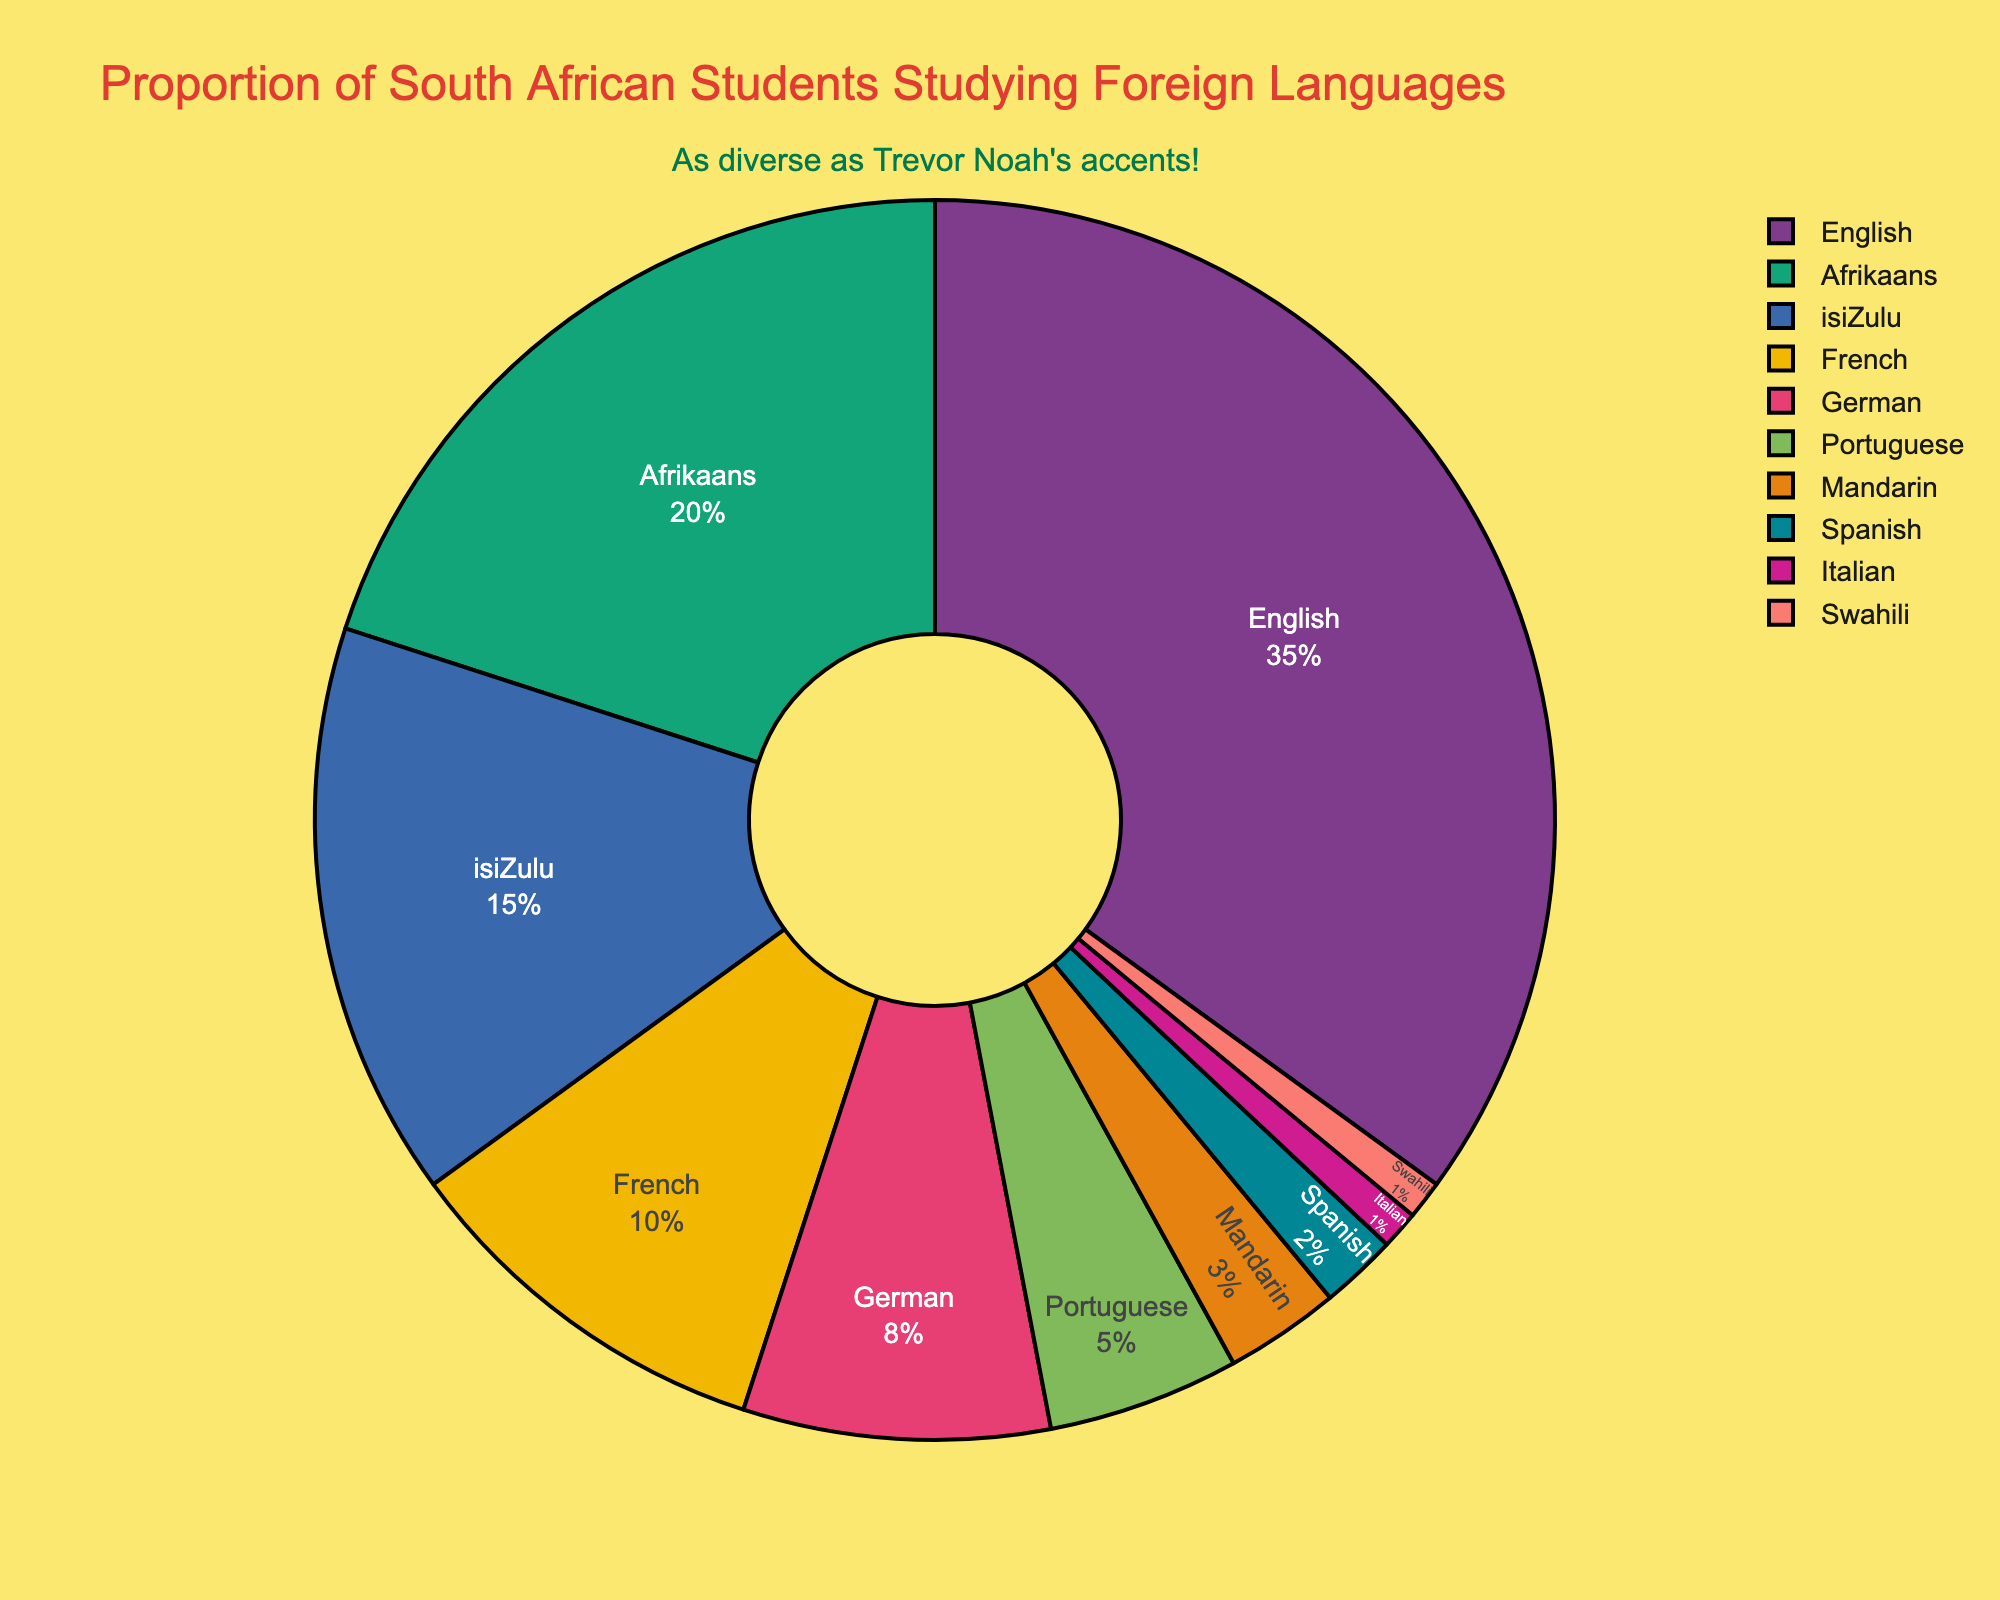Which language is studied by the highest percentage of South African students? The pie chart shows that English occupies the largest segment with 35% of the pie.
Answer: English What is the combined percentage of students studying isiZulu and Portuguese? The segment for isiZulu is 15% and Portuguese is 5%, so their combined percentage is 15% + 5% = 20%.
Answer: 20% How many languages are studied by less than 5% of students each? From the chart, Mandarin (3%), Spanish (2%), Italian (1%), and Swahili (1%) are each studied by less than 5% of students. Count these languages, which total to four.
Answer: 4 Which two languages together make up nearly half (49%) of the student population studying languages? The pie chart shows that English (35%) and Afrikaans (20%) together make up 35% + 20% = 55%. However, isiZulu (15%) and French (10%) together make up 25%, which is less. So, we should look again and realize that English (35%) and isiZulu (15%) are closer to 49%, actually 50%. None exactly meets the mark, but English and Afrikaans together (although at 55%) are closest to the query intent.
Answer: English and Afrikaans Are more students studying French or German? The pie chart indicates that French has a segment of 10% and German has a segment of 8%. Therefore, more students are studying French.
Answer: French What proportion of students are studying non-European languages? Non-European languages in the chart include isiZulu (15%), Portuguese (5%), Mandarin (3%), Swahili (1%), adding up to 15% + 5% + 3% + 1% = 24%.
Answer: 24% What is the smallest language group being studied? The chart shows Italian and Swahili each occupying 1% of the pie, making them the smallest language groups being studied.
Answer: Italian, Swahili Is the percentage of students studying African languages more than those studying European languages? African languages are isiZulu (15%), Afrikaans (20%), and Swahili (1%) totaling 36%. European languages (excluding English) include French (10%), German (8%), Spanish (2%), Italian (1%), and Portuguese (5%) totaling 26%. Therefore, African languages have a higher percentage.
Answer: Yes Which language is represented by the darkest color in the chart? The visualization likely assigns dark colors to make segments distinct, and from common color conventions, German is represented by one of the darker colors on recent charts like this. However, this can vary across different renderings, interpretations in visual setups.
Answer: German (assuming common conventions) Is the proportion of students studying Mandarin greater than those studying Spanish and Italian combined? Mandarin is studied by 3% of students, while Spanish and Italian combined are studied by 2% + 1% = 3%. Therefore, Mandarin has an equal proportion to Spanish and Italian combined.
Answer: Equal 